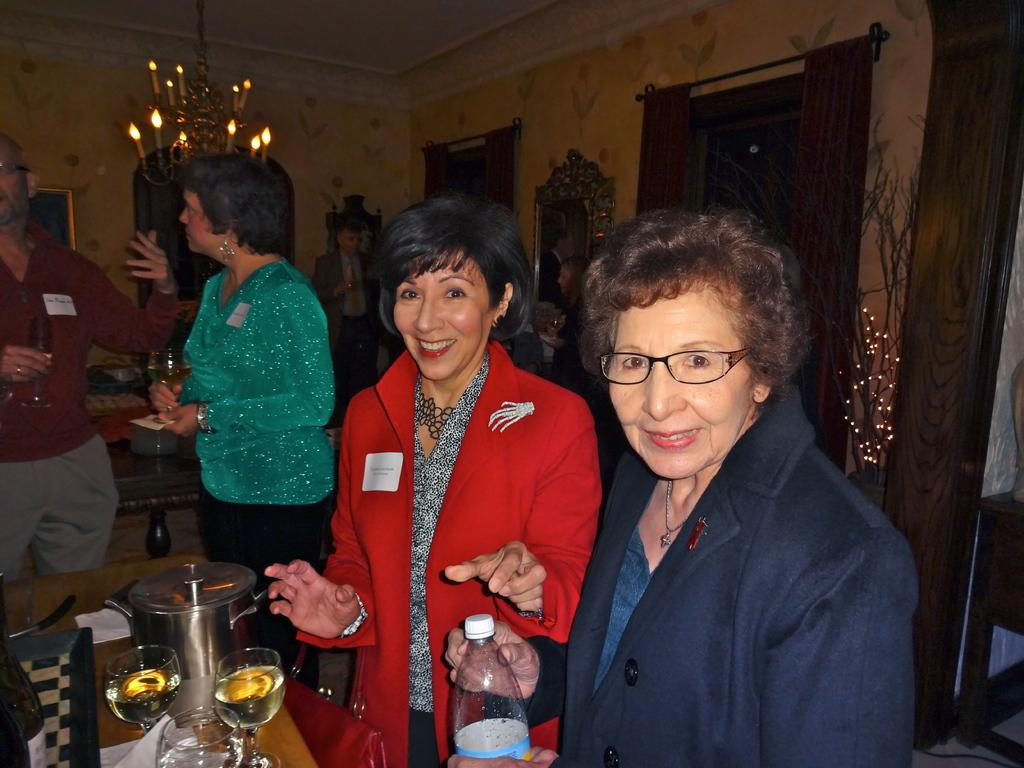What are the two women in the image doing? The two women in the image are standing and laughing. What is the woman on the left holding? The woman on the left is holding a wine glass. What is the woman with the wine glass looking at? The woman with the wine glass is looking at something. Can you describe the background of the image? There is another woman behind them and a curtain visible in the image. What type of train is passing by in the image? There is no train present in the image. 